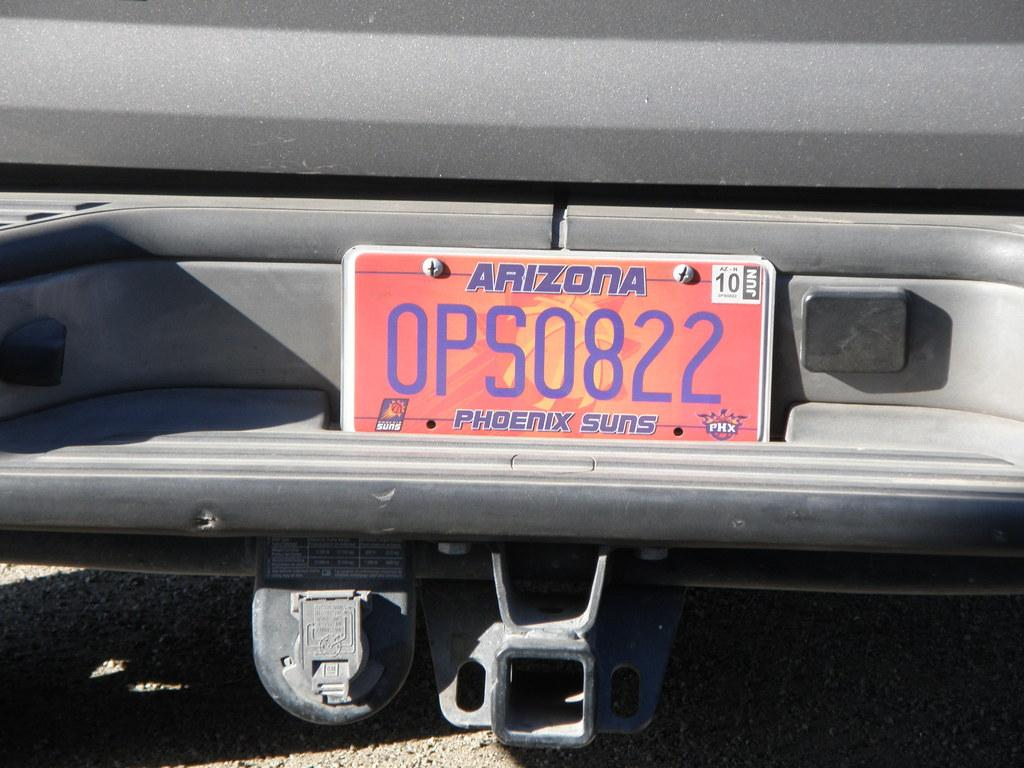What is the color of the main object in the image? The main object in the image is ash color. What is attached to the ash color object? There is a red and orange color board attached to the object. What can be seen on the board? Something is written on the board. Can you see any waves crashing on the shore in the image? There are no waves or shore visible in the image. What type of insurance policy is advertised on the board in the image? There is no insurance policy mentioned or advertised on the board in the image. 